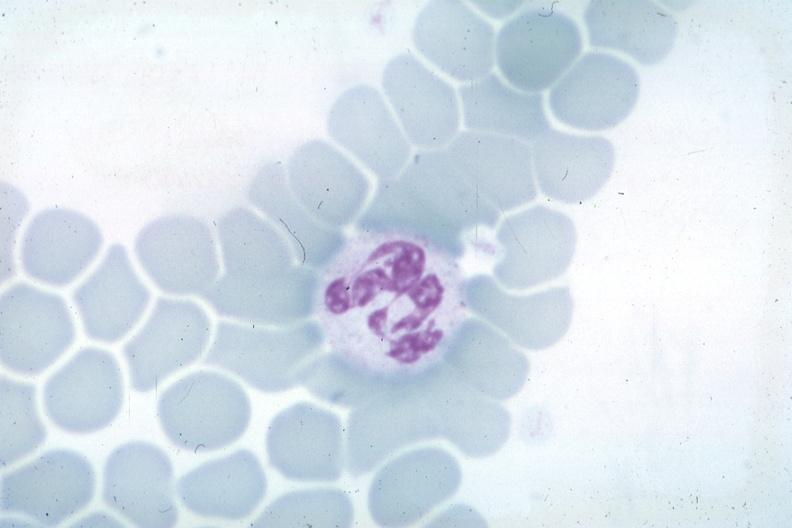how is wrights not the best photograph for color but nuclear change obvious source?
Answer the question using a single word or phrase. Unknown 